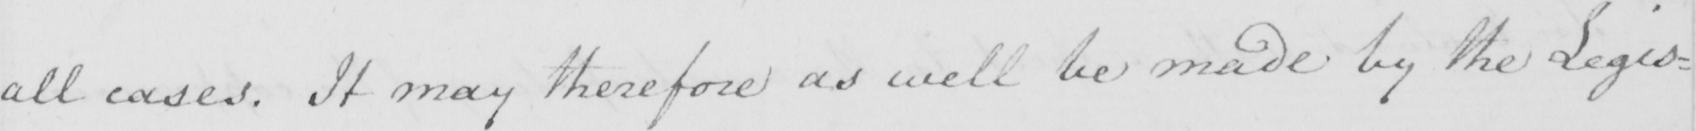What is written in this line of handwriting? all cases . It may therefore as well be made by the Legis= 